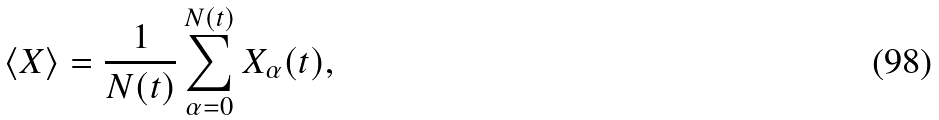<formula> <loc_0><loc_0><loc_500><loc_500>\langle X \rangle = \frac { 1 } { N ( t ) } \sum _ { \alpha = 0 } ^ { N ( t ) } X _ { \alpha } ( t ) ,</formula> 